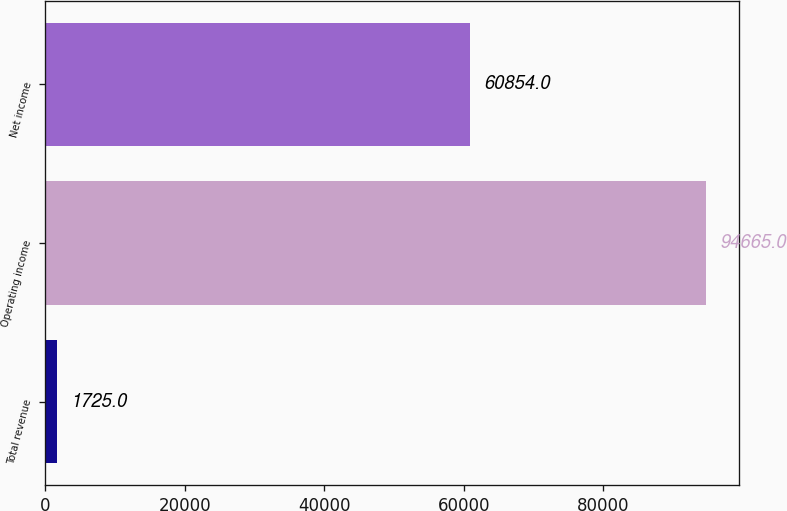Convert chart. <chart><loc_0><loc_0><loc_500><loc_500><bar_chart><fcel>Total revenue<fcel>Operating income<fcel>Net income<nl><fcel>1725<fcel>94665<fcel>60854<nl></chart> 